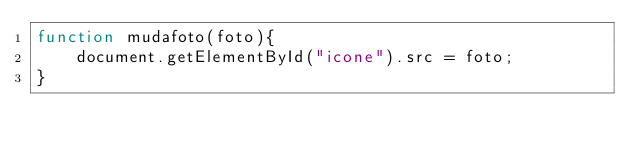Convert code to text. <code><loc_0><loc_0><loc_500><loc_500><_JavaScript_>function mudafoto(foto){
		document.getElementById("icone").src = foto;
}</code> 